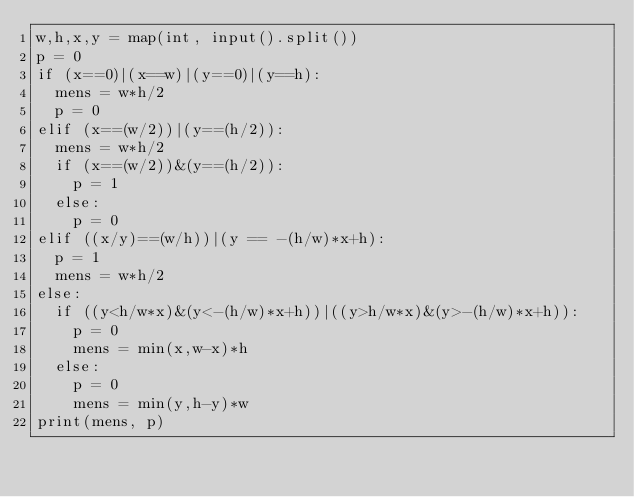Convert code to text. <code><loc_0><loc_0><loc_500><loc_500><_Python_>w,h,x,y = map(int, input().split())
p = 0
if (x==0)|(x==w)|(y==0)|(y==h):
  mens = w*h/2
  p = 0
elif (x==(w/2))|(y==(h/2)):
  mens = w*h/2
  if (x==(w/2))&(y==(h/2)):
    p = 1
  else:
    p = 0
elif ((x/y)==(w/h))|(y == -(h/w)*x+h):
  p = 1
  mens = w*h/2
else:
  if ((y<h/w*x)&(y<-(h/w)*x+h))|((y>h/w*x)&(y>-(h/w)*x+h)):
    p = 0
    mens = min(x,w-x)*h
  else:
    p = 0
    mens = min(y,h-y)*w
print(mens, p)</code> 